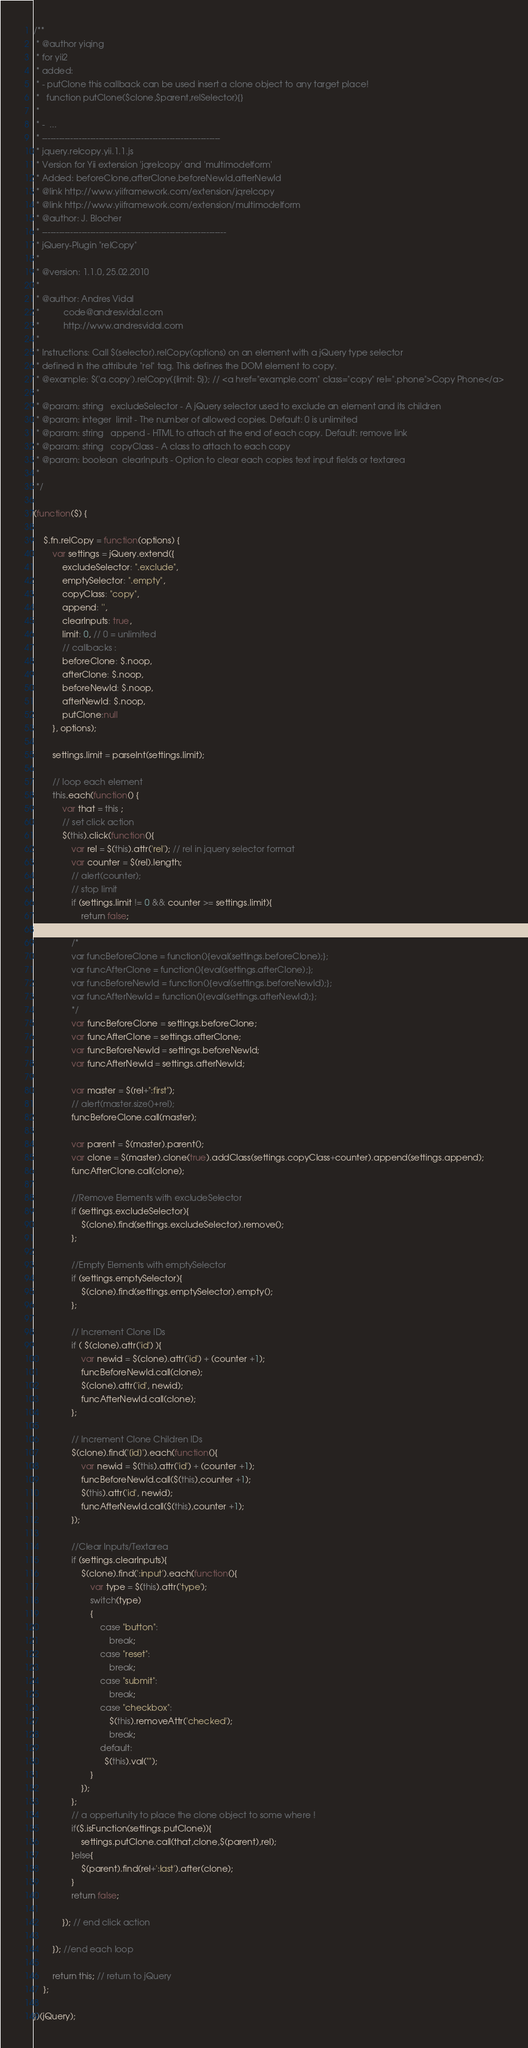<code> <loc_0><loc_0><loc_500><loc_500><_JavaScript_>/**
 * @author yiqing
 * for yii2
 * added:
 * - putClone this callback can be used insert a clone object to any target place!
 *   function putClone($clone,$parent,relSelector){}
 *
 * -  ...
 * ---------------------------------------------------------------
 * jquery.relcopy.yii.1.1.js
 * Version for Yii extension 'jqrelcopy' and 'multimodelform'
 * Added: beforeClone,afterClone,beforeNewId,afterNewId
 * @link http://www.yiiframework.com/extension/jqrelcopy
 * @link http://www.yiiframework.com/extension/multimodelform
 * @author: J. Blocher
 * -----------------------------------------------------------------
 * jQuery-Plugin "relCopy"
 *
 * @version: 1.1.0, 25.02.2010
 *
 * @author: Andres Vidal
 *          code@andresvidal.com
 *          http://www.andresvidal.com
 *
 * Instructions: Call $(selector).relCopy(options) on an element with a jQuery type selector
 * defined in the attribute "rel" tag. This defines the DOM element to copy.
 * @example: $('a.copy').relCopy({limit: 5}); // <a href="example.com" class="copy" rel=".phone">Copy Phone</a>
 *
 * @param: string	excludeSelector - A jQuery selector used to exclude an element and its children
 * @param: integer	limit - The number of allowed copies. Default: 0 is unlimited
 * @param: string	append - HTML to attach at the end of each copy. Default: remove link
 * @param: string	copyClass - A class to attach to each copy
 * @param: boolean	clearInputs - Option to clear each copies text input fields or textarea
 *
 */

(function($) {

	$.fn.relCopy = function(options) {
		var settings = jQuery.extend({
			excludeSelector: ".exclude",
			emptySelector: ".empty",
			copyClass: "copy",
			append: '',
			clearInputs: true,
			limit: 0, // 0 = unlimited
			// callbacks :
			beforeClone: $.noop,
			afterClone: $.noop,
			beforeNewId: $.noop,
			afterNewId: $.noop,
			putClone:null
		}, options);

		settings.limit = parseInt(settings.limit);

		// loop each element
		this.each(function() {
            var that = this ;
			// set click action
			$(this).click(function(){
				var rel = $(this).attr('rel'); // rel in jquery selector format
				var counter = $(rel).length;
                // alert(counter);
				// stop limit
				if (settings.limit != 0 && counter >= settings.limit){
					return false;
				};
                /*
				var funcBeforeClone = function(){eval(settings.beforeClone);};
				var funcAfterClone = function(){eval(settings.afterClone);};
				var funcBeforeNewId = function(){eval(settings.beforeNewId);};
				var funcAfterNewId = function(){eval(settings.afterNewId);};
				*/
				var funcBeforeClone = settings.beforeClone;
				var funcAfterClone = settings.afterClone;
				var funcBeforeNewId = settings.beforeNewId;
				var funcAfterNewId = settings.afterNewId;

				var master = $(rel+":first");
				// alert(master.size()+rel);
				funcBeforeClone.call(master);

				var parent = $(master).parent();
				var clone = $(master).clone(true).addClass(settings.copyClass+counter).append(settings.append);
                funcAfterClone.call(clone);

				//Remove Elements with excludeSelector
				if (settings.excludeSelector){
					$(clone).find(settings.excludeSelector).remove();
				};

				//Empty Elements with emptySelector
				if (settings.emptySelector){
					$(clone).find(settings.emptySelector).empty();
				};

				// Increment Clone IDs
				if ( $(clone).attr('id') ){
					var newid = $(clone).attr('id') + (counter +1);
					funcBeforeNewId.call(clone);
					$(clone).attr('id', newid);
				    funcAfterNewId.call(clone);
				};

				// Increment Clone Children IDs
				$(clone).find('[id]').each(function(){
					var newid = $(this).attr('id') + (counter +1);
					funcBeforeNewId.call($(this),counter +1);
					$(this).attr('id', newid);
					funcAfterNewId.call($(this),counter +1);
				});

				//Clear Inputs/Textarea
				if (settings.clearInputs){
					$(clone).find(':input').each(function(){
						var type = $(this).attr('type');
						switch(type)
						{
							case "button":
								break;
							case "reset":
								break;
							case "submit":
								break;
							case "checkbox":
								$(this).removeAttr('checked');
								break;
							default:
							  $(this).val("");
						}
					});
				};
                // a oppertunity to place the clone object to some where !
				if($.isFunction(settings.putClone)){
					settings.putClone.call(that,clone,$(parent),rel);
				}else{
					$(parent).find(rel+':last').after(clone);
				}
				return false;

			}); // end click action

		}); //end each loop

		return this; // return to jQuery
	};

})(jQuery);</code> 